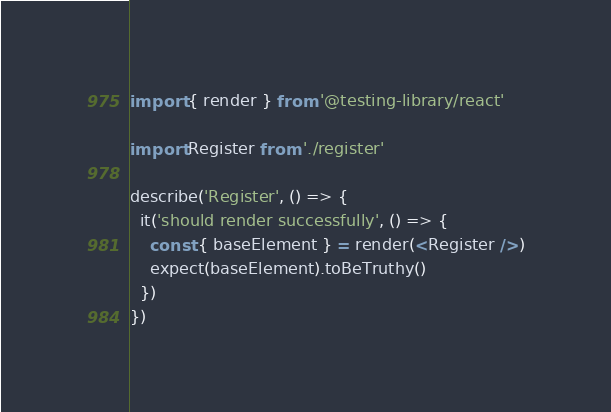Convert code to text. <code><loc_0><loc_0><loc_500><loc_500><_TypeScript_>import { render } from '@testing-library/react'

import Register from './register'

describe('Register', () => {
  it('should render successfully', () => {
    const { baseElement } = render(<Register />)
    expect(baseElement).toBeTruthy()
  })
})
</code> 